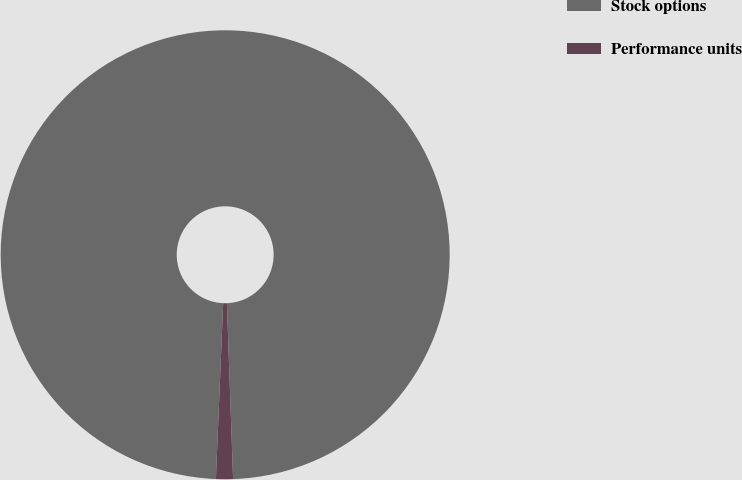Convert chart to OTSL. <chart><loc_0><loc_0><loc_500><loc_500><pie_chart><fcel>Stock options<fcel>Performance units<nl><fcel>98.78%<fcel>1.22%<nl></chart> 